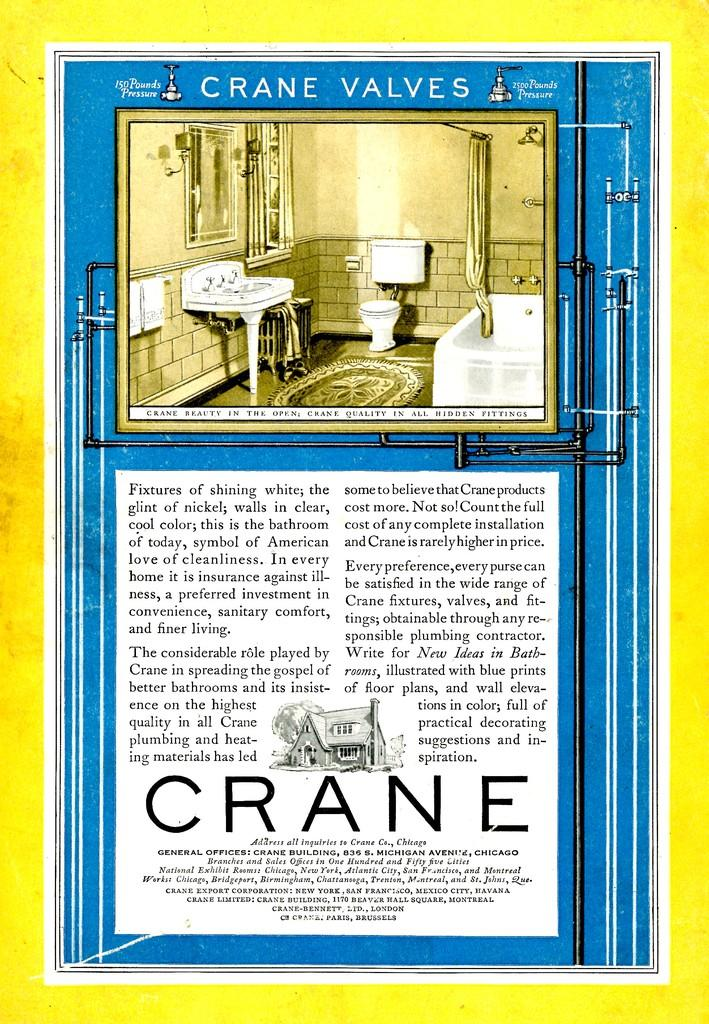What is the main subject of the poster in the image? The main subject of the poster in the image is a toilet room. What is the style of the text on the poster? The text on the poster is in black and white. What color is the border of the poster? The border of the poster is yellow. How does the locket on the poster contribute to reducing pollution in the image? There is no locket present in the image, and the poster does not address pollution. 